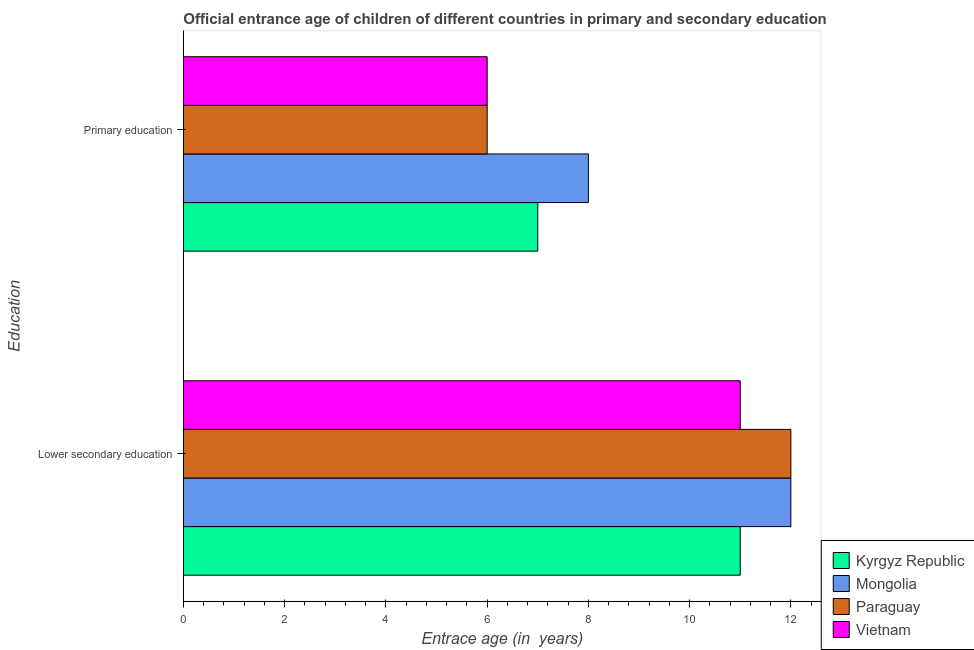Are the number of bars on each tick of the Y-axis equal?
Your answer should be very brief. Yes. How many bars are there on the 2nd tick from the top?
Keep it short and to the point. 4. Across all countries, what is the maximum entrance age of children in lower secondary education?
Make the answer very short. 12. In which country was the entrance age of children in lower secondary education maximum?
Your answer should be very brief. Mongolia. In which country was the entrance age of children in lower secondary education minimum?
Your answer should be very brief. Kyrgyz Republic. What is the total entrance age of children in lower secondary education in the graph?
Your answer should be compact. 46. What is the difference between the entrance age of chiildren in primary education in Mongolia and that in Vietnam?
Provide a short and direct response. 2. What is the difference between the entrance age of children in lower secondary education in Kyrgyz Republic and the entrance age of chiildren in primary education in Paraguay?
Keep it short and to the point. 5. What is the average entrance age of children in lower secondary education per country?
Provide a short and direct response. 11.5. What is the difference between the entrance age of children in lower secondary education and entrance age of chiildren in primary education in Paraguay?
Offer a very short reply. 6. In how many countries, is the entrance age of children in lower secondary education greater than 6.4 years?
Provide a short and direct response. 4. What is the ratio of the entrance age of children in lower secondary education in Vietnam to that in Paraguay?
Your answer should be very brief. 0.92. Is the entrance age of children in lower secondary education in Mongolia less than that in Kyrgyz Republic?
Make the answer very short. No. In how many countries, is the entrance age of children in lower secondary education greater than the average entrance age of children in lower secondary education taken over all countries?
Offer a terse response. 2. What does the 2nd bar from the top in Lower secondary education represents?
Keep it short and to the point. Paraguay. What does the 2nd bar from the bottom in Primary education represents?
Keep it short and to the point. Mongolia. What is the difference between two consecutive major ticks on the X-axis?
Your answer should be compact. 2. Are the values on the major ticks of X-axis written in scientific E-notation?
Ensure brevity in your answer.  No. How are the legend labels stacked?
Provide a succinct answer. Vertical. What is the title of the graph?
Your answer should be compact. Official entrance age of children of different countries in primary and secondary education. Does "Tajikistan" appear as one of the legend labels in the graph?
Provide a short and direct response. No. What is the label or title of the X-axis?
Your answer should be compact. Entrace age (in  years). What is the label or title of the Y-axis?
Offer a terse response. Education. What is the Entrace age (in  years) in Kyrgyz Republic in Lower secondary education?
Make the answer very short. 11. What is the Entrace age (in  years) of Mongolia in Lower secondary education?
Your response must be concise. 12. What is the Entrace age (in  years) in Mongolia in Primary education?
Provide a succinct answer. 8. What is the Entrace age (in  years) in Paraguay in Primary education?
Your answer should be very brief. 6. Across all Education, what is the maximum Entrace age (in  years) in Mongolia?
Provide a succinct answer. 12. Across all Education, what is the maximum Entrace age (in  years) of Paraguay?
Your answer should be compact. 12. Across all Education, what is the maximum Entrace age (in  years) in Vietnam?
Make the answer very short. 11. Across all Education, what is the minimum Entrace age (in  years) in Kyrgyz Republic?
Ensure brevity in your answer.  7. Across all Education, what is the minimum Entrace age (in  years) in Mongolia?
Make the answer very short. 8. What is the total Entrace age (in  years) of Kyrgyz Republic in the graph?
Offer a terse response. 18. What is the total Entrace age (in  years) in Mongolia in the graph?
Ensure brevity in your answer.  20. What is the difference between the Entrace age (in  years) in Paraguay in Lower secondary education and that in Primary education?
Give a very brief answer. 6. What is the difference between the Entrace age (in  years) of Kyrgyz Republic in Lower secondary education and the Entrace age (in  years) of Mongolia in Primary education?
Provide a succinct answer. 3. What is the difference between the Entrace age (in  years) in Kyrgyz Republic in Lower secondary education and the Entrace age (in  years) in Vietnam in Primary education?
Ensure brevity in your answer.  5. What is the difference between the Entrace age (in  years) of Mongolia in Lower secondary education and the Entrace age (in  years) of Vietnam in Primary education?
Keep it short and to the point. 6. What is the difference between the Entrace age (in  years) in Paraguay in Lower secondary education and the Entrace age (in  years) in Vietnam in Primary education?
Ensure brevity in your answer.  6. What is the average Entrace age (in  years) of Kyrgyz Republic per Education?
Give a very brief answer. 9. What is the average Entrace age (in  years) in Mongolia per Education?
Give a very brief answer. 10. What is the average Entrace age (in  years) of Paraguay per Education?
Your response must be concise. 9. What is the difference between the Entrace age (in  years) of Kyrgyz Republic and Entrace age (in  years) of Mongolia in Lower secondary education?
Keep it short and to the point. -1. What is the difference between the Entrace age (in  years) of Kyrgyz Republic and Entrace age (in  years) of Paraguay in Lower secondary education?
Provide a short and direct response. -1. What is the difference between the Entrace age (in  years) of Paraguay and Entrace age (in  years) of Vietnam in Lower secondary education?
Your response must be concise. 1. What is the difference between the Entrace age (in  years) of Kyrgyz Republic and Entrace age (in  years) of Mongolia in Primary education?
Provide a short and direct response. -1. What is the difference between the Entrace age (in  years) of Mongolia and Entrace age (in  years) of Paraguay in Primary education?
Provide a short and direct response. 2. What is the difference between the Entrace age (in  years) in Mongolia and Entrace age (in  years) in Vietnam in Primary education?
Ensure brevity in your answer.  2. What is the difference between the Entrace age (in  years) of Paraguay and Entrace age (in  years) of Vietnam in Primary education?
Offer a very short reply. 0. What is the ratio of the Entrace age (in  years) of Kyrgyz Republic in Lower secondary education to that in Primary education?
Provide a succinct answer. 1.57. What is the ratio of the Entrace age (in  years) of Mongolia in Lower secondary education to that in Primary education?
Your answer should be very brief. 1.5. What is the ratio of the Entrace age (in  years) in Paraguay in Lower secondary education to that in Primary education?
Your response must be concise. 2. What is the ratio of the Entrace age (in  years) of Vietnam in Lower secondary education to that in Primary education?
Provide a succinct answer. 1.83. What is the difference between the highest and the second highest Entrace age (in  years) of Mongolia?
Provide a succinct answer. 4. What is the difference between the highest and the lowest Entrace age (in  years) in Kyrgyz Republic?
Give a very brief answer. 4. 